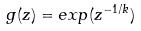<formula> <loc_0><loc_0><loc_500><loc_500>g ( z ) = e x p ( z ^ { - 1 / k } )</formula> 